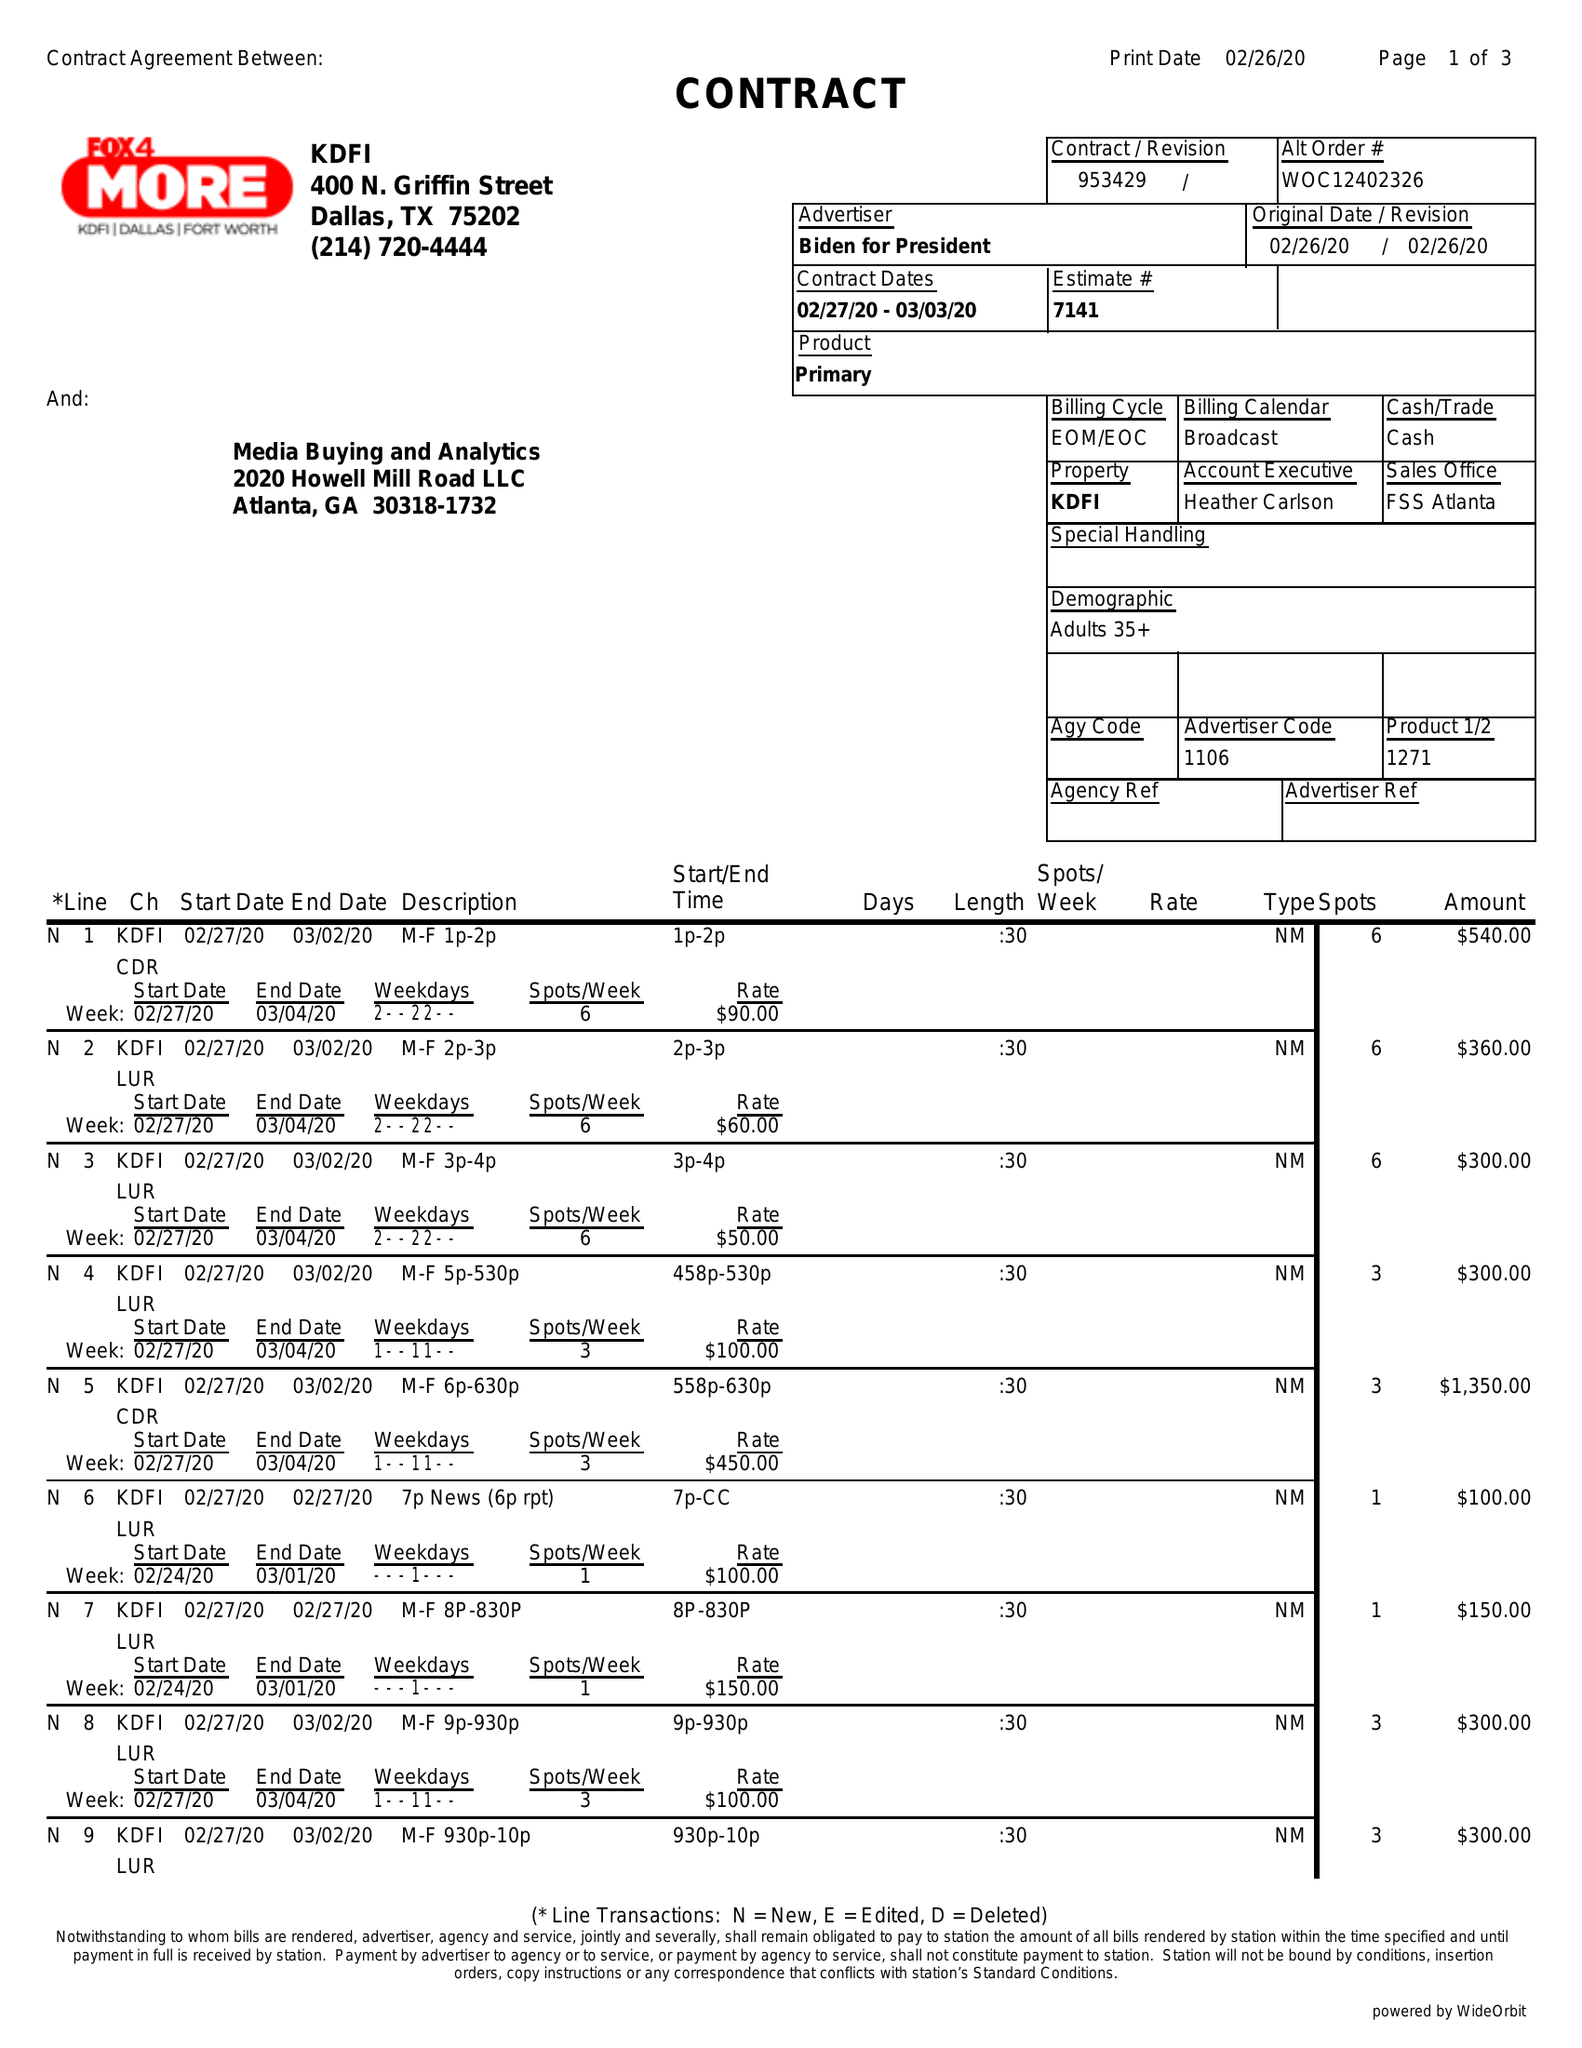What is the value for the advertiser?
Answer the question using a single word or phrase. BIDEN FOR PRESIDENT 